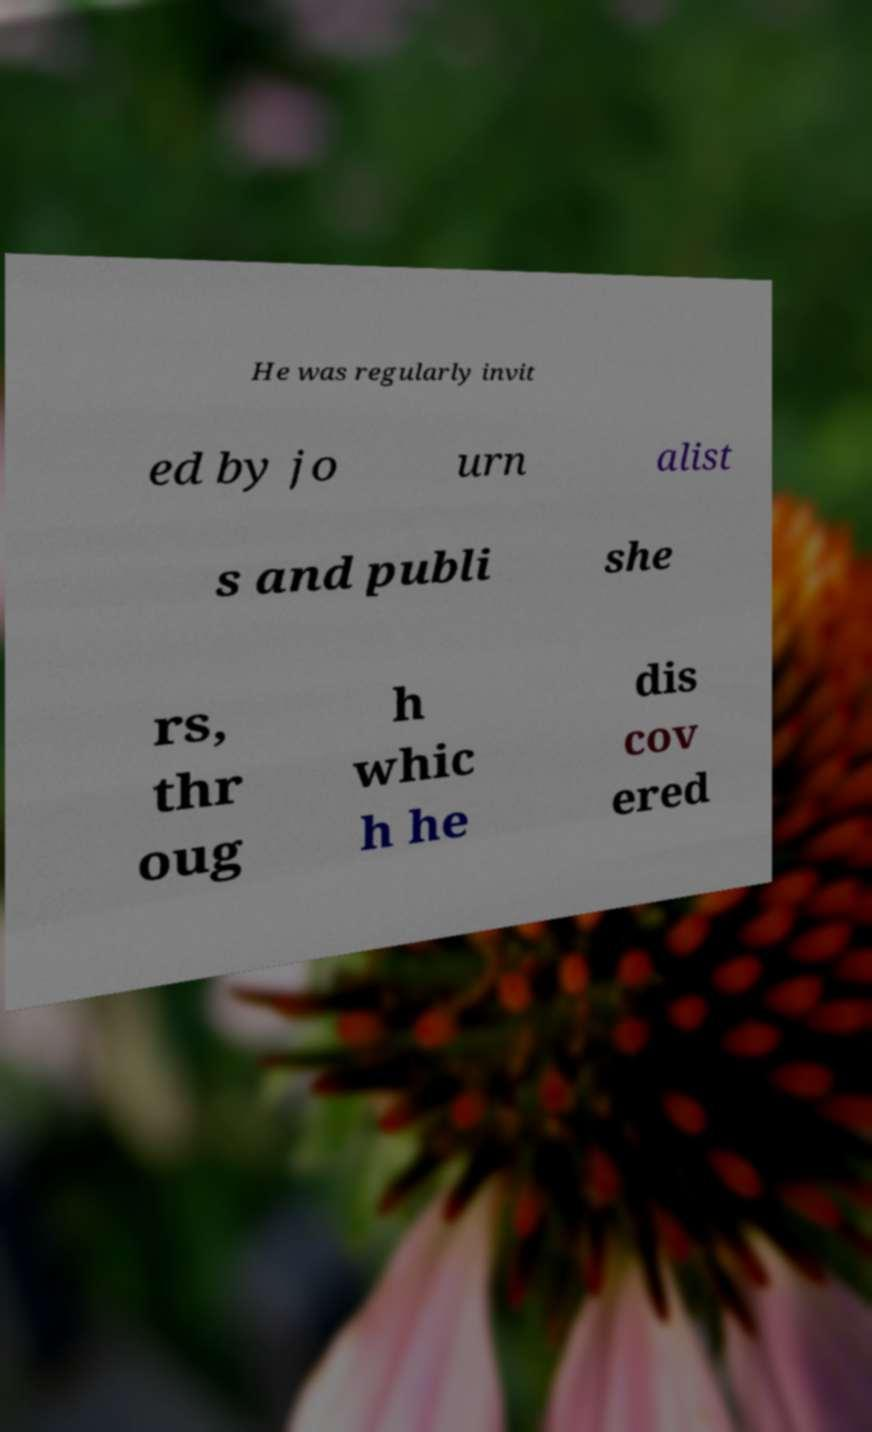Please identify and transcribe the text found in this image. He was regularly invit ed by jo urn alist s and publi she rs, thr oug h whic h he dis cov ered 